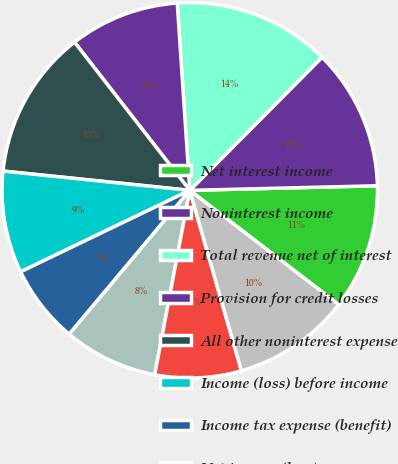Convert chart. <chart><loc_0><loc_0><loc_500><loc_500><pie_chart><fcel>Net interest income<fcel>Noninterest income<fcel>Total revenue net of interest<fcel>Provision for credit losses<fcel>All other noninterest expense<fcel>Income (loss) before income<fcel>Income tax expense (benefit)<fcel>Net income (loss)<fcel>Net income (loss) applicable<fcel>Average common shares issued<nl><fcel>10.81%<fcel>12.16%<fcel>13.51%<fcel>9.46%<fcel>12.84%<fcel>8.78%<fcel>6.76%<fcel>8.11%<fcel>7.43%<fcel>10.14%<nl></chart> 